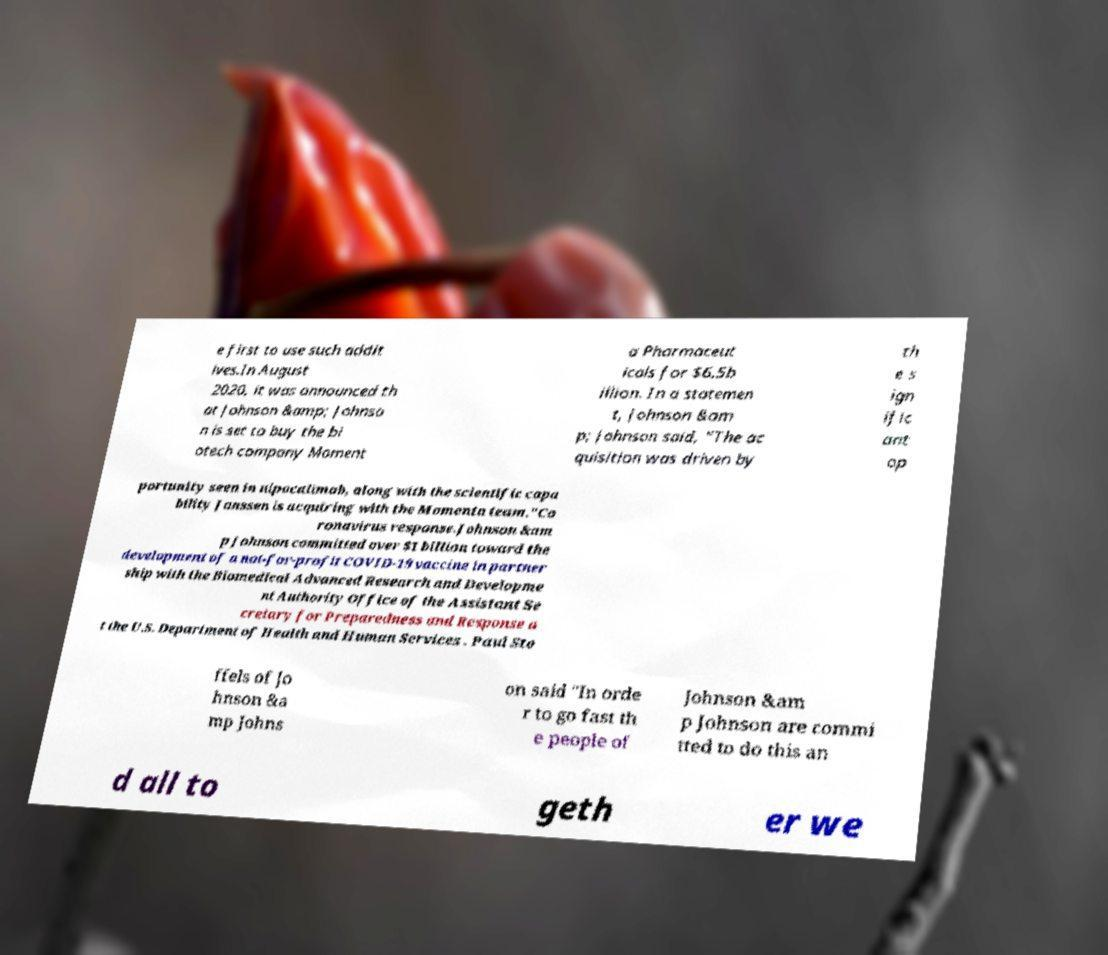What messages or text are displayed in this image? I need them in a readable, typed format. e first to use such addit ives.In August 2020, it was announced th at Johnson &amp; Johnso n is set to buy the bi otech company Moment a Pharmaceut icals for $6.5b illion. In a statemen t, Johnson &am p; Johnson said, "The ac quisition was driven by th e s ign ific ant op portunity seen in nipocalimab, along with the scientific capa bility Janssen is acquiring with the Momenta team."Co ronavirus response.Johnson &am p Johnson committed over $1 billion toward the development of a not-for-profit COVID-19 vaccine in partner ship with the Biomedical Advanced Research and Developme nt Authority Office of the Assistant Se cretary for Preparedness and Response a t the U.S. Department of Health and Human Services . Paul Sto ffels of Jo hnson &a mp Johns on said "In orde r to go fast th e people of Johnson &am p Johnson are commi tted to do this an d all to geth er we 